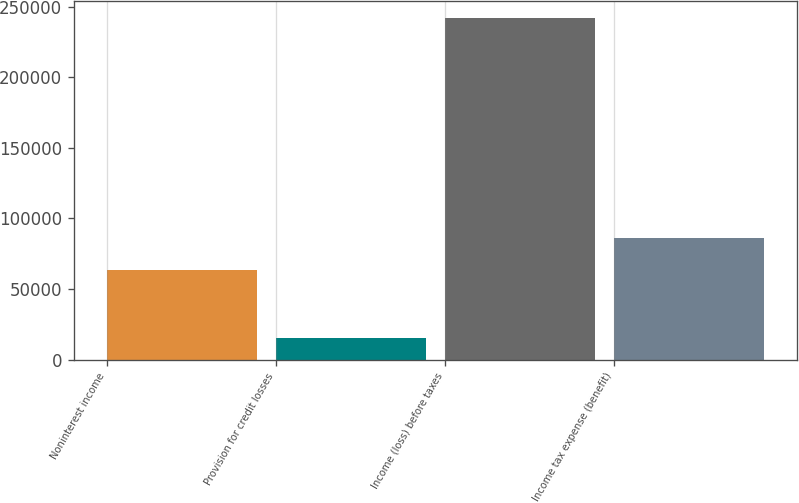<chart> <loc_0><loc_0><loc_500><loc_500><bar_chart><fcel>Noninterest income<fcel>Provision for credit losses<fcel>Income (loss) before taxes<fcel>Income tax expense (benefit)<nl><fcel>63288<fcel>15507<fcel>241769<fcel>85914.2<nl></chart> 